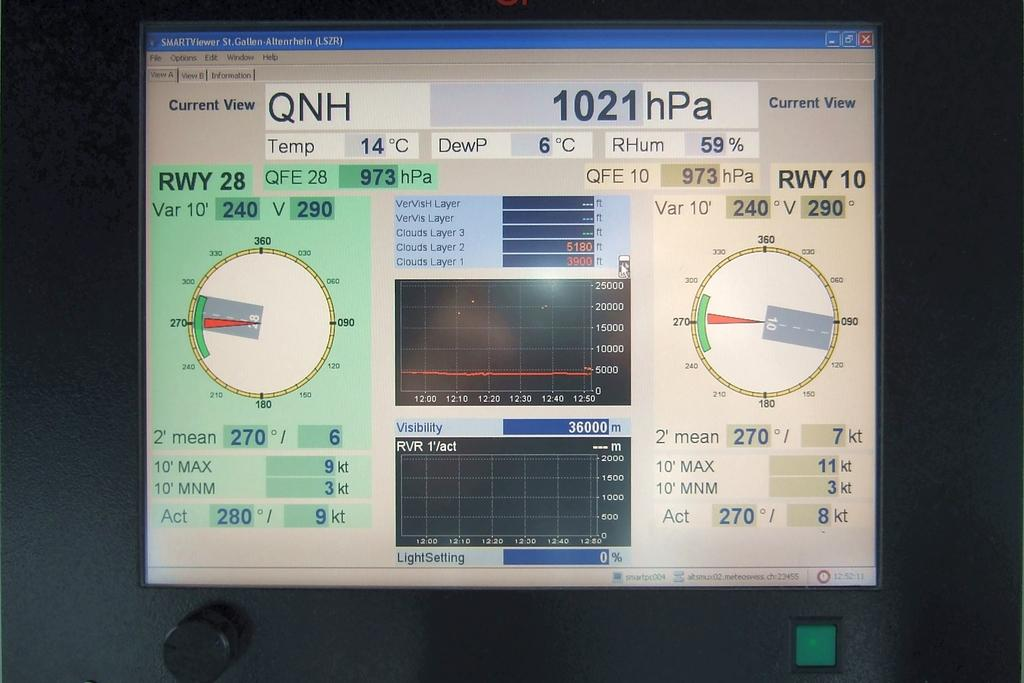What is the main object in the image? There is a screen in the image. What can be seen on the screen? There is text or content on the screen. How would you describe the overall appearance of the image? The background of the image is dark. Can you identify any specific elements on the screen or around it? Yes, there is a green button in the image. How many cows are playing volleyball in the image? There are no cows or volleyballs present in the image. Is there an oven visible in the image? No, there is no oven present in the image. 